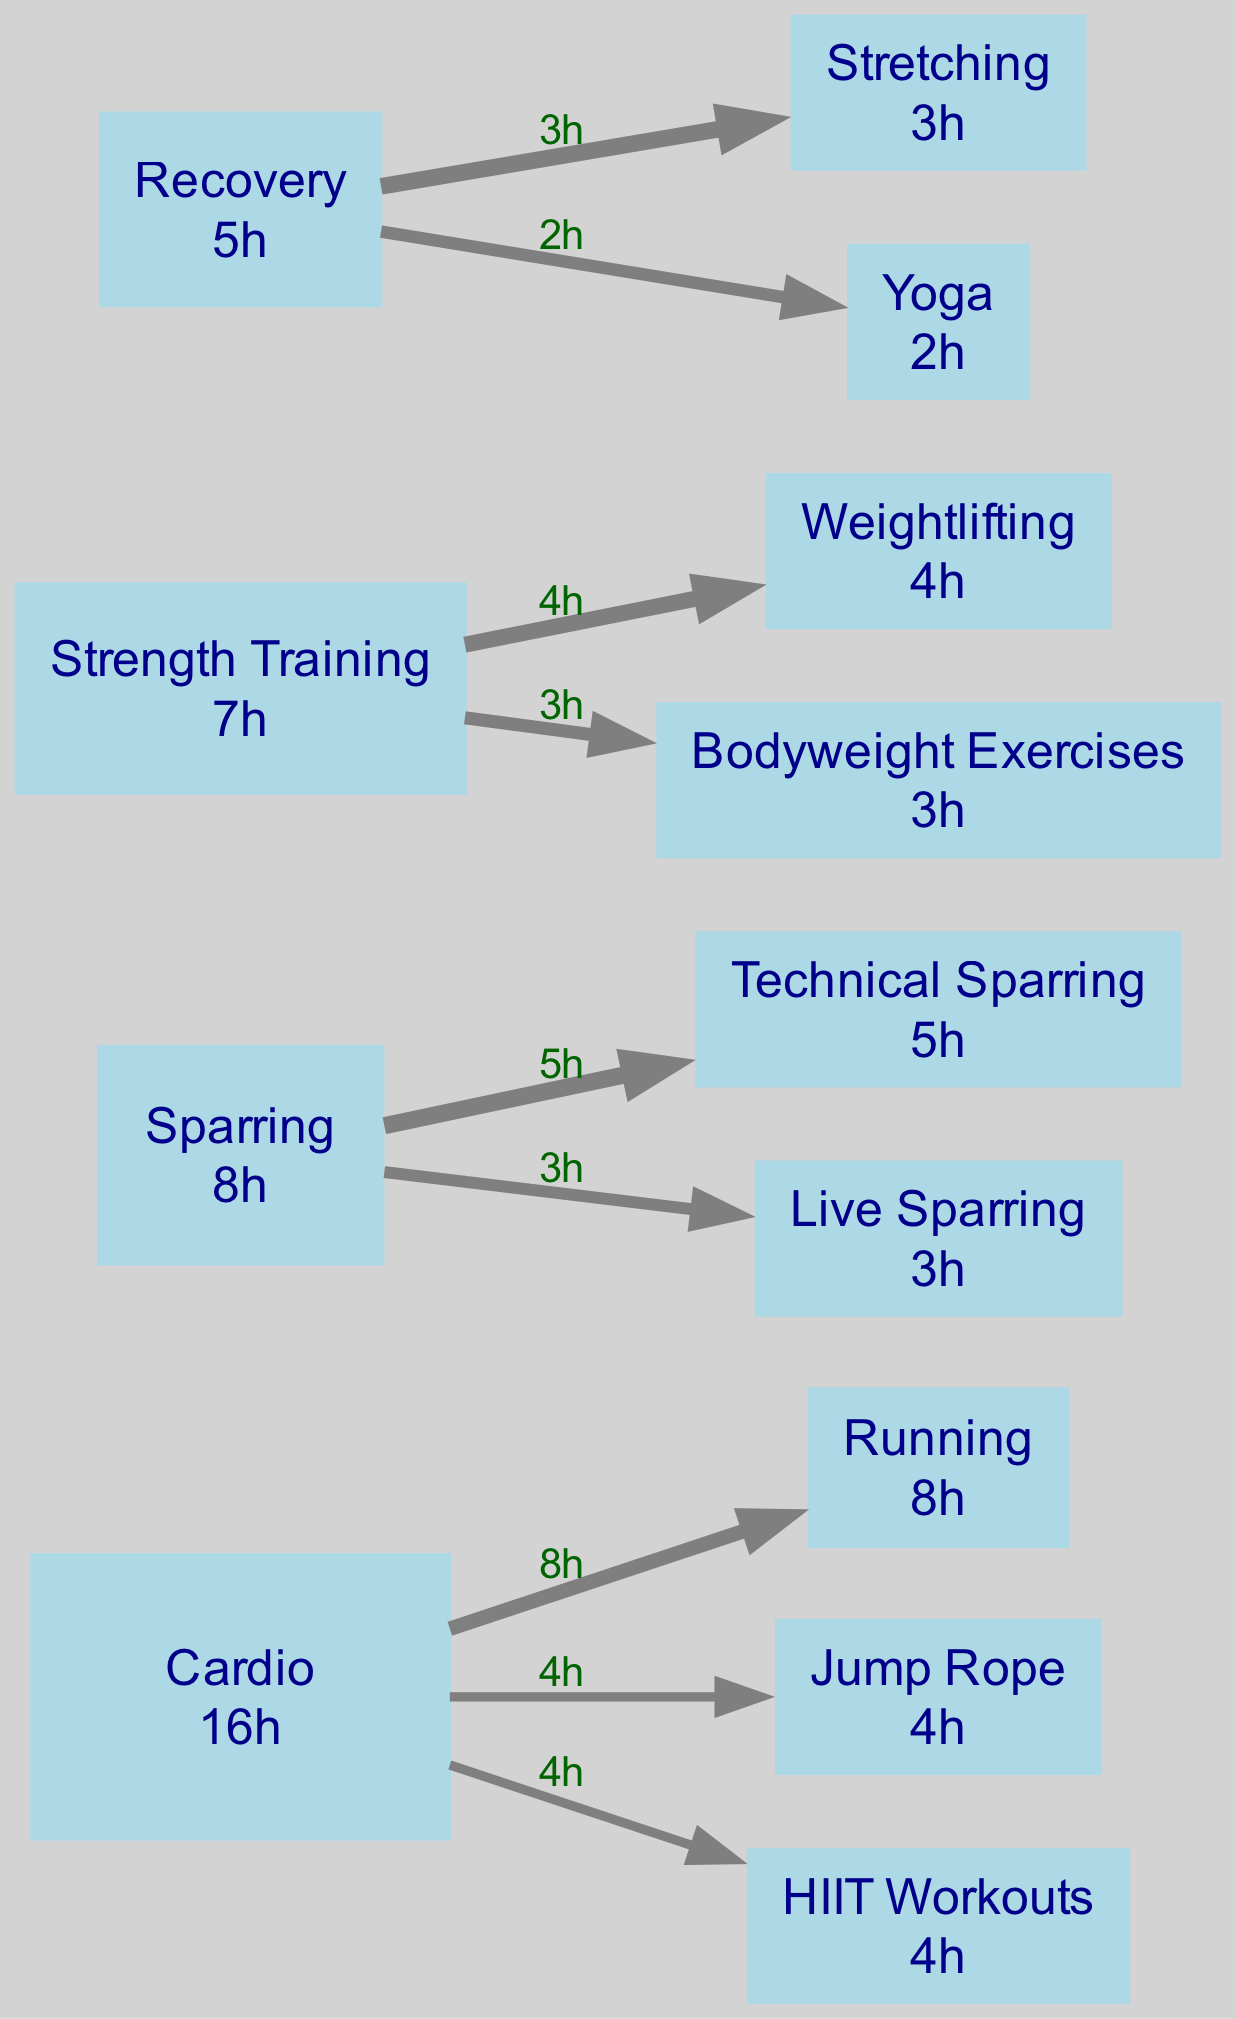What is the total training hours for cardio? The cardio category has three subcategories: Running (8 hours), Jump Rope (4 hours), and HIIT Workouts (4 hours). Adding these hours together, we get 8 + 4 + 4 = 16 hours total for cardio.
Answer: 16 hours Which subcategory has the highest training hours? The subcategories for cardio are Running (8), Jump Rope (4), and HIIT Workouts (4). For sparring, we have Technical Sparring (5) and Live Sparring (3). Strength training subcategories are Weightlifting (4) and Bodyweight Exercises (3). Lastly, recovery has Stretching (3) and Yoga (2). Comparing all these hours, Running has the highest at 8 hours.
Answer: Running How many total subcategories are there? The categories and their respective subcategories are: Cardio (3), Sparring (2), Strength Training (2), and Recovery (2). We add these numbers: 3 + 2 + 2 + 2 = 9 subcategories in total.
Answer: 9 What is the relationship between Strength Training and Weightlifting? Strength Training is a category that contains multiple subcategories, one of which is Weightlifting, which has 4 hours of training allocated to it. Thus, there is a direct relationship where Weightlifting is a subcategory under Strength Training.
Answer: Subcategory What percent of total hours is spent on Recovery? First, calculate the total hours from all categories: Cardio (16), Sparring (8), Strength Training (7), and Recovery (5), which sums up to 16 + 8 + 7 + 5 = 36 hours total. Recovery contributes 5 hours, therefore, the percentage is (5/36) * 100 ≈ 13.89%.
Answer: 13.89% How many edges are coming out of the Cardio category? In the Cardio category, there are three subcategories: Running, Jump Rope, and HIIT Workouts. Each of these creates a directed edge from Cardio to each subcategory, resulting in 3 edges emanating from the Cardio category.
Answer: 3 edges Which category has fewer total hours than Cardio? The total hours for Cardio is 16 hours. Sparring has 8 hours and Recovery has 5 hours. Strength Training has 7 hours, which also is less than Cardio’s total, making Strength Training and Recovery the answer.
Answer: Strength Training, Recovery What is the total number of hours attributed to Sparring? Sparring comprises Technical Sparring (5 hours) and Live Sparring (3 hours). Adding these together gives: 5 + 3 = 8 hours total for Sparring.
Answer: 8 hours Which type of exercise under Recovery has the least training hours? The Recovery category has two subtypes: Stretching (3 hours) and Yoga (2 hours). Comparing these values, Yoga contributes the least training hours at 2 hours.
Answer: Yoga 